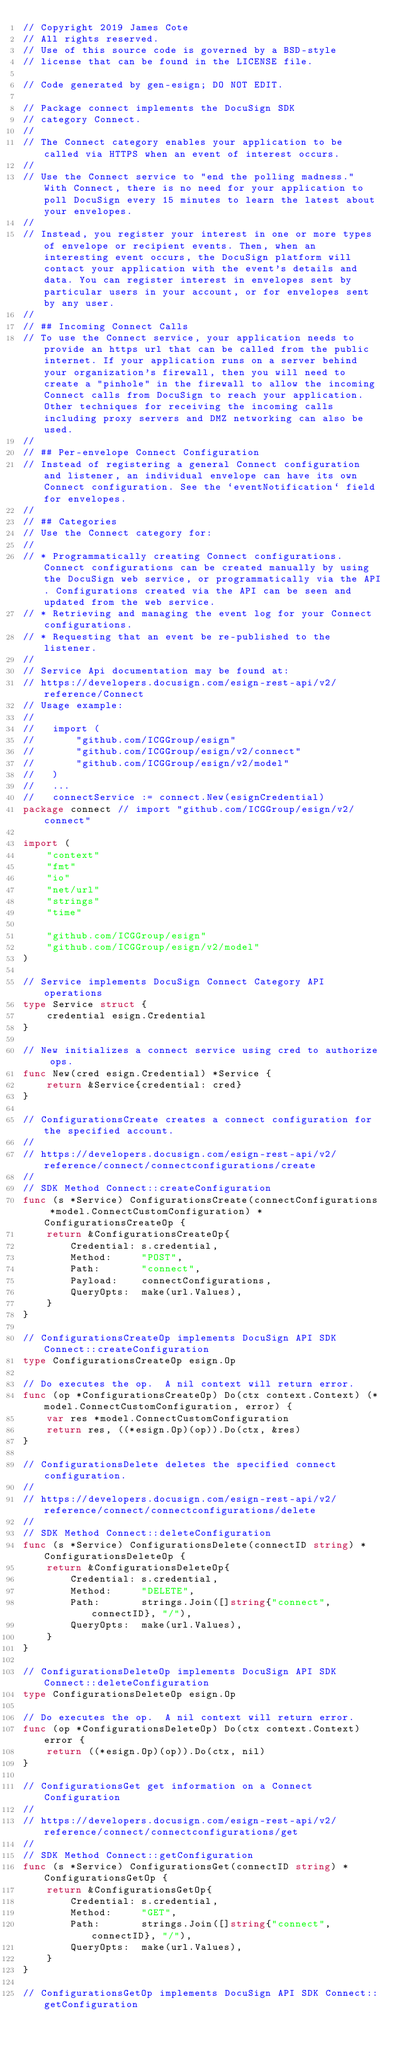Convert code to text. <code><loc_0><loc_0><loc_500><loc_500><_Go_>// Copyright 2019 James Cote
// All rights reserved.
// Use of this source code is governed by a BSD-style
// license that can be found in the LICENSE file.

// Code generated by gen-esign; DO NOT EDIT.

// Package connect implements the DocuSign SDK
// category Connect.
//
// The Connect category enables your application to be called via HTTPS when an event of interest occurs.
//
// Use the Connect service to "end the polling madness." With Connect, there is no need for your application to poll DocuSign every 15 minutes to learn the latest about your envelopes.
//
// Instead, you register your interest in one or more types of envelope or recipient events. Then, when an interesting event occurs, the DocuSign platform will contact your application with the event's details and data. You can register interest in envelopes sent by particular users in your account, or for envelopes sent by any user.
//
// ## Incoming Connect Calls
// To use the Connect service, your application needs to provide an https url that can be called from the public internet. If your application runs on a server behind your organization's firewall, then you will need to create a "pinhole" in the firewall to allow the incoming Connect calls from DocuSign to reach your application. Other techniques for receiving the incoming calls including proxy servers and DMZ networking can also be used.
//
// ## Per-envelope Connect Configuration
// Instead of registering a general Connect configuration and listener, an individual envelope can have its own Connect configuration. See the `eventNotification` field for envelopes.
//
// ## Categories
// Use the Connect category for:
//
// * Programmatically creating Connect configurations. Connect configurations can be created manually by using the DocuSign web service, or programmatically via the API. Configurations created via the API can be seen and updated from the web service.
// * Retrieving and managing the event log for your Connect configurations.
// * Requesting that an event be re-published to the listener.
//
// Service Api documentation may be found at:
// https://developers.docusign.com/esign-rest-api/v2/reference/Connect
// Usage example:
//
//   import (
//       "github.com/ICGGroup/esign"
//       "github.com/ICGGroup/esign/v2/connect"
//       "github.com/ICGGroup/esign/v2/model"
//   )
//   ...
//   connectService := connect.New(esignCredential)
package connect // import "github.com/ICGGroup/esign/v2/connect"

import (
	"context"
	"fmt"
	"io"
	"net/url"
	"strings"
	"time"

	"github.com/ICGGroup/esign"
	"github.com/ICGGroup/esign/v2/model"
)

// Service implements DocuSign Connect Category API operations
type Service struct {
	credential esign.Credential
}

// New initializes a connect service using cred to authorize ops.
func New(cred esign.Credential) *Service {
	return &Service{credential: cred}
}

// ConfigurationsCreate creates a connect configuration for the specified account.
//
// https://developers.docusign.com/esign-rest-api/v2/reference/connect/connectconfigurations/create
//
// SDK Method Connect::createConfiguration
func (s *Service) ConfigurationsCreate(connectConfigurations *model.ConnectCustomConfiguration) *ConfigurationsCreateOp {
	return &ConfigurationsCreateOp{
		Credential: s.credential,
		Method:     "POST",
		Path:       "connect",
		Payload:    connectConfigurations,
		QueryOpts:  make(url.Values),
	}
}

// ConfigurationsCreateOp implements DocuSign API SDK Connect::createConfiguration
type ConfigurationsCreateOp esign.Op

// Do executes the op.  A nil context will return error.
func (op *ConfigurationsCreateOp) Do(ctx context.Context) (*model.ConnectCustomConfiguration, error) {
	var res *model.ConnectCustomConfiguration
	return res, ((*esign.Op)(op)).Do(ctx, &res)
}

// ConfigurationsDelete deletes the specified connect configuration.
//
// https://developers.docusign.com/esign-rest-api/v2/reference/connect/connectconfigurations/delete
//
// SDK Method Connect::deleteConfiguration
func (s *Service) ConfigurationsDelete(connectID string) *ConfigurationsDeleteOp {
	return &ConfigurationsDeleteOp{
		Credential: s.credential,
		Method:     "DELETE",
		Path:       strings.Join([]string{"connect", connectID}, "/"),
		QueryOpts:  make(url.Values),
	}
}

// ConfigurationsDeleteOp implements DocuSign API SDK Connect::deleteConfiguration
type ConfigurationsDeleteOp esign.Op

// Do executes the op.  A nil context will return error.
func (op *ConfigurationsDeleteOp) Do(ctx context.Context) error {
	return ((*esign.Op)(op)).Do(ctx, nil)
}

// ConfigurationsGet get information on a Connect Configuration
//
// https://developers.docusign.com/esign-rest-api/v2/reference/connect/connectconfigurations/get
//
// SDK Method Connect::getConfiguration
func (s *Service) ConfigurationsGet(connectID string) *ConfigurationsGetOp {
	return &ConfigurationsGetOp{
		Credential: s.credential,
		Method:     "GET",
		Path:       strings.Join([]string{"connect", connectID}, "/"),
		QueryOpts:  make(url.Values),
	}
}

// ConfigurationsGetOp implements DocuSign API SDK Connect::getConfiguration</code> 